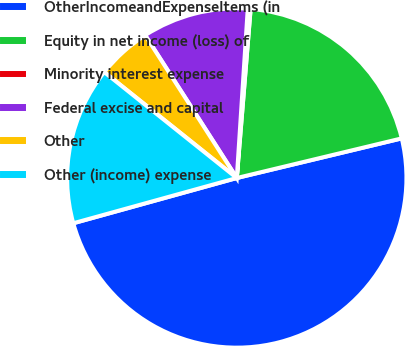Convert chart. <chart><loc_0><loc_0><loc_500><loc_500><pie_chart><fcel>OtherIncomeandExpenseItems (in<fcel>Equity in net income (loss) of<fcel>Minority interest expense<fcel>Federal excise and capital<fcel>Other<fcel>Other (income) expense<nl><fcel>49.46%<fcel>19.95%<fcel>0.27%<fcel>10.11%<fcel>5.19%<fcel>15.03%<nl></chart> 